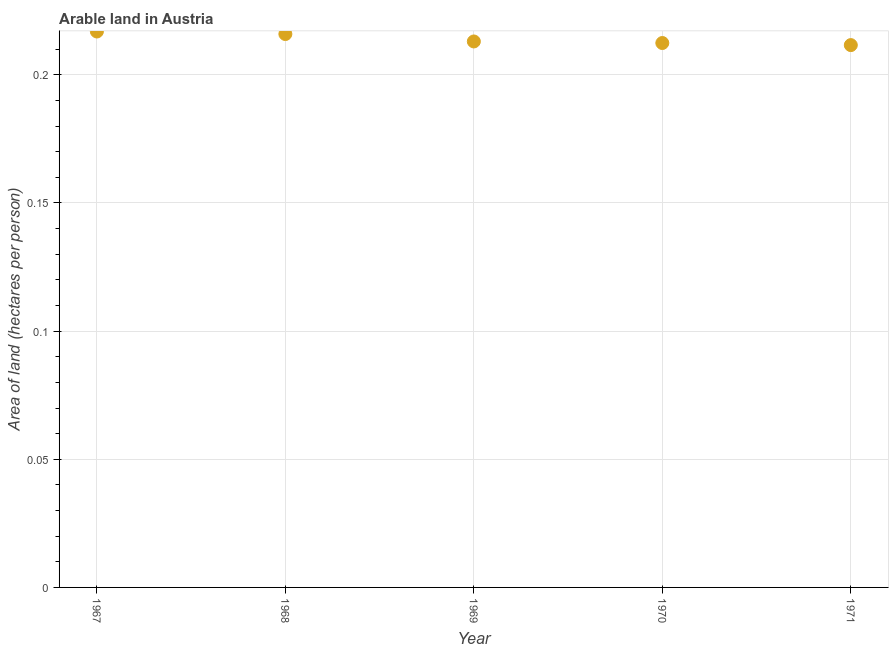What is the area of arable land in 1967?
Give a very brief answer. 0.22. Across all years, what is the maximum area of arable land?
Your answer should be compact. 0.22. Across all years, what is the minimum area of arable land?
Keep it short and to the point. 0.21. In which year was the area of arable land maximum?
Give a very brief answer. 1967. What is the sum of the area of arable land?
Provide a short and direct response. 1.07. What is the difference between the area of arable land in 1970 and 1971?
Ensure brevity in your answer.  0. What is the average area of arable land per year?
Offer a terse response. 0.21. What is the median area of arable land?
Keep it short and to the point. 0.21. Do a majority of the years between 1967 and 1971 (inclusive) have area of arable land greater than 0.19000000000000003 hectares per person?
Keep it short and to the point. Yes. What is the ratio of the area of arable land in 1969 to that in 1971?
Ensure brevity in your answer.  1.01. Is the area of arable land in 1967 less than that in 1968?
Provide a short and direct response. No. Is the difference between the area of arable land in 1967 and 1969 greater than the difference between any two years?
Your response must be concise. No. What is the difference between the highest and the second highest area of arable land?
Give a very brief answer. 0. Is the sum of the area of arable land in 1967 and 1970 greater than the maximum area of arable land across all years?
Provide a succinct answer. Yes. What is the difference between the highest and the lowest area of arable land?
Offer a terse response. 0.01. Are the values on the major ticks of Y-axis written in scientific E-notation?
Offer a very short reply. No. Does the graph contain any zero values?
Ensure brevity in your answer.  No. What is the title of the graph?
Make the answer very short. Arable land in Austria. What is the label or title of the X-axis?
Make the answer very short. Year. What is the label or title of the Y-axis?
Give a very brief answer. Area of land (hectares per person). What is the Area of land (hectares per person) in 1967?
Provide a succinct answer. 0.22. What is the Area of land (hectares per person) in 1968?
Keep it short and to the point. 0.22. What is the Area of land (hectares per person) in 1969?
Keep it short and to the point. 0.21. What is the Area of land (hectares per person) in 1970?
Provide a succinct answer. 0.21. What is the Area of land (hectares per person) in 1971?
Offer a terse response. 0.21. What is the difference between the Area of land (hectares per person) in 1967 and 1968?
Give a very brief answer. 0. What is the difference between the Area of land (hectares per person) in 1967 and 1969?
Keep it short and to the point. 0. What is the difference between the Area of land (hectares per person) in 1967 and 1970?
Offer a terse response. 0. What is the difference between the Area of land (hectares per person) in 1967 and 1971?
Your answer should be compact. 0.01. What is the difference between the Area of land (hectares per person) in 1968 and 1969?
Give a very brief answer. 0. What is the difference between the Area of land (hectares per person) in 1968 and 1970?
Give a very brief answer. 0. What is the difference between the Area of land (hectares per person) in 1968 and 1971?
Offer a very short reply. 0. What is the difference between the Area of land (hectares per person) in 1969 and 1970?
Provide a short and direct response. 0. What is the difference between the Area of land (hectares per person) in 1969 and 1971?
Offer a very short reply. 0. What is the difference between the Area of land (hectares per person) in 1970 and 1971?
Your answer should be very brief. 0. What is the ratio of the Area of land (hectares per person) in 1967 to that in 1968?
Your answer should be compact. 1. What is the ratio of the Area of land (hectares per person) in 1967 to that in 1969?
Provide a short and direct response. 1.02. What is the ratio of the Area of land (hectares per person) in 1967 to that in 1970?
Offer a very short reply. 1.02. What is the ratio of the Area of land (hectares per person) in 1967 to that in 1971?
Your answer should be compact. 1.02. What is the ratio of the Area of land (hectares per person) in 1968 to that in 1970?
Your answer should be very brief. 1.02. What is the ratio of the Area of land (hectares per person) in 1968 to that in 1971?
Your answer should be very brief. 1.02. What is the ratio of the Area of land (hectares per person) in 1969 to that in 1971?
Make the answer very short. 1.01. 